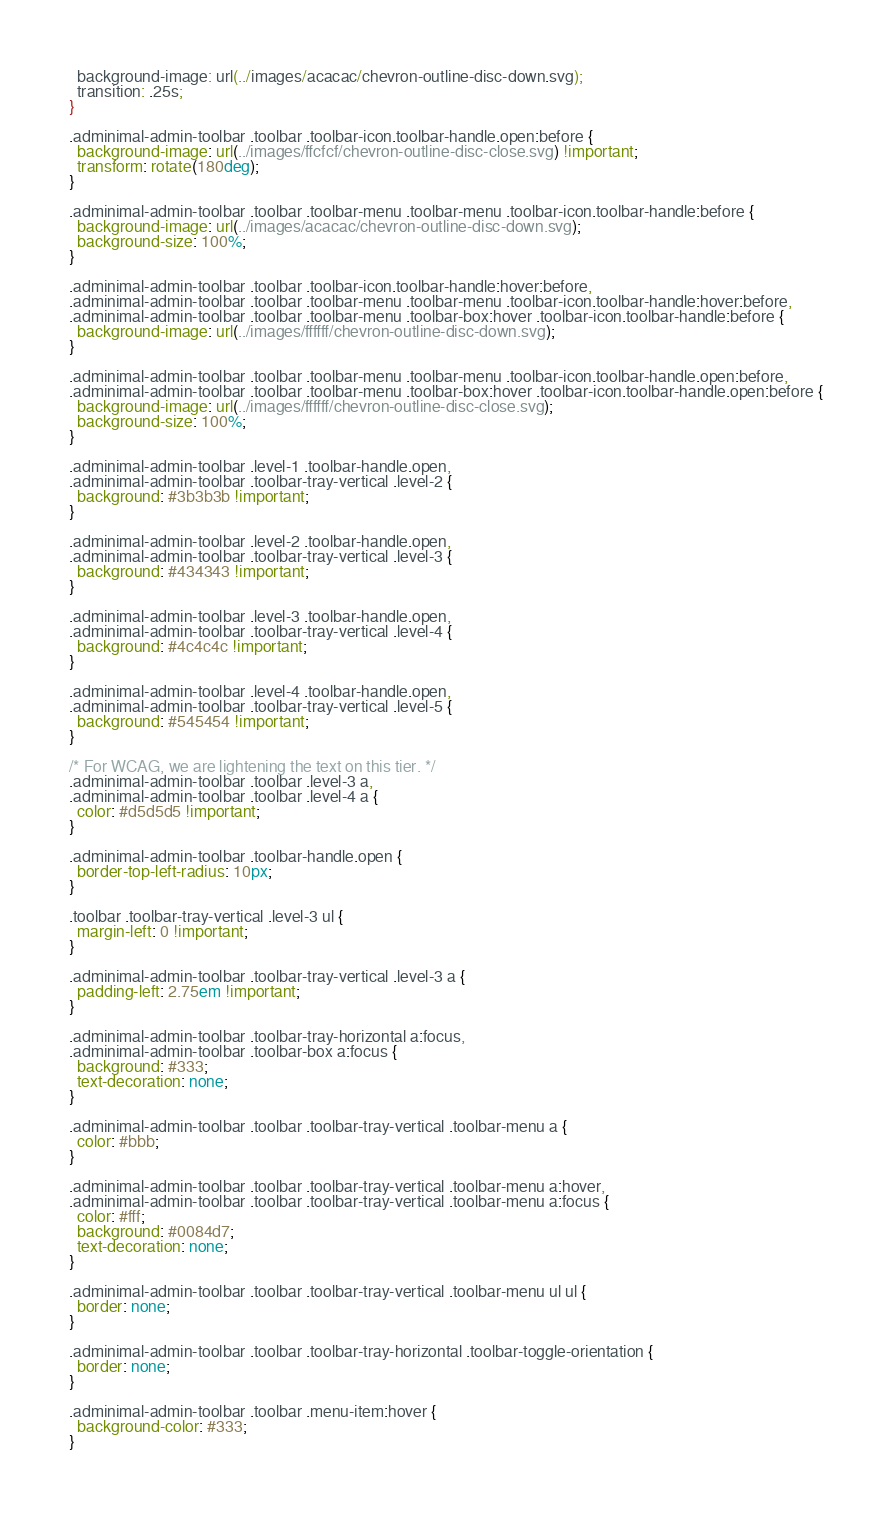Convert code to text. <code><loc_0><loc_0><loc_500><loc_500><_CSS_>  background-image: url(../images/acacac/chevron-outline-disc-down.svg);
  transition: .25s;
}

.adminimal-admin-toolbar .toolbar .toolbar-icon.toolbar-handle.open:before {
  background-image: url(../images/ffcfcf/chevron-outline-disc-close.svg) !important;
  transform: rotate(180deg);
}

.adminimal-admin-toolbar .toolbar .toolbar-menu .toolbar-menu .toolbar-icon.toolbar-handle:before {
  background-image: url(../images/acacac/chevron-outline-disc-down.svg);
  background-size: 100%;
}

.adminimal-admin-toolbar .toolbar .toolbar-icon.toolbar-handle:hover:before,
.adminimal-admin-toolbar .toolbar .toolbar-menu .toolbar-menu .toolbar-icon.toolbar-handle:hover:before,
.adminimal-admin-toolbar .toolbar .toolbar-menu .toolbar-box:hover .toolbar-icon.toolbar-handle:before {
  background-image: url(../images/ffffff/chevron-outline-disc-down.svg);
}

.adminimal-admin-toolbar .toolbar .toolbar-menu .toolbar-menu .toolbar-icon.toolbar-handle.open:before,
.adminimal-admin-toolbar .toolbar .toolbar-menu .toolbar-box:hover .toolbar-icon.toolbar-handle.open:before {
  background-image: url(../images/ffffff/chevron-outline-disc-close.svg);
  background-size: 100%;
}

.adminimal-admin-toolbar .level-1 .toolbar-handle.open,
.adminimal-admin-toolbar .toolbar-tray-vertical .level-2 {
  background: #3b3b3b !important;
}

.adminimal-admin-toolbar .level-2 .toolbar-handle.open,
.adminimal-admin-toolbar .toolbar-tray-vertical .level-3 {
  background: #434343 !important;
}

.adminimal-admin-toolbar .level-3 .toolbar-handle.open,
.adminimal-admin-toolbar .toolbar-tray-vertical .level-4 {
  background: #4c4c4c !important;
}

.adminimal-admin-toolbar .level-4 .toolbar-handle.open,
.adminimal-admin-toolbar .toolbar-tray-vertical .level-5 {
  background: #545454 !important;
}

/* For WCAG, we are lightening the text on this tier. */
.adminimal-admin-toolbar .toolbar .level-3 a,
.adminimal-admin-toolbar .toolbar .level-4 a {
  color: #d5d5d5 !important;
}

.adminimal-admin-toolbar .toolbar-handle.open {
  border-top-left-radius: 10px;
}

.toolbar .toolbar-tray-vertical .level-3 ul {
  margin-left: 0 !important;
}

.adminimal-admin-toolbar .toolbar-tray-vertical .level-3 a {
  padding-left: 2.75em !important;
}

.adminimal-admin-toolbar .toolbar-tray-horizontal a:focus,
.adminimal-admin-toolbar .toolbar-box a:focus {
  background: #333;
  text-decoration: none;
}

.adminimal-admin-toolbar .toolbar .toolbar-tray-vertical .toolbar-menu a {
  color: #bbb;
}

.adminimal-admin-toolbar .toolbar .toolbar-tray-vertical .toolbar-menu a:hover,
.adminimal-admin-toolbar .toolbar .toolbar-tray-vertical .toolbar-menu a:focus {
  color: #fff;
  background: #0084d7;
  text-decoration: none;
}

.adminimal-admin-toolbar .toolbar .toolbar-tray-vertical .toolbar-menu ul ul {
  border: none;
}

.adminimal-admin-toolbar .toolbar .toolbar-tray-horizontal .toolbar-toggle-orientation {
  border: none;
}

.adminimal-admin-toolbar .toolbar .menu-item:hover {
  background-color: #333;
}
</code> 